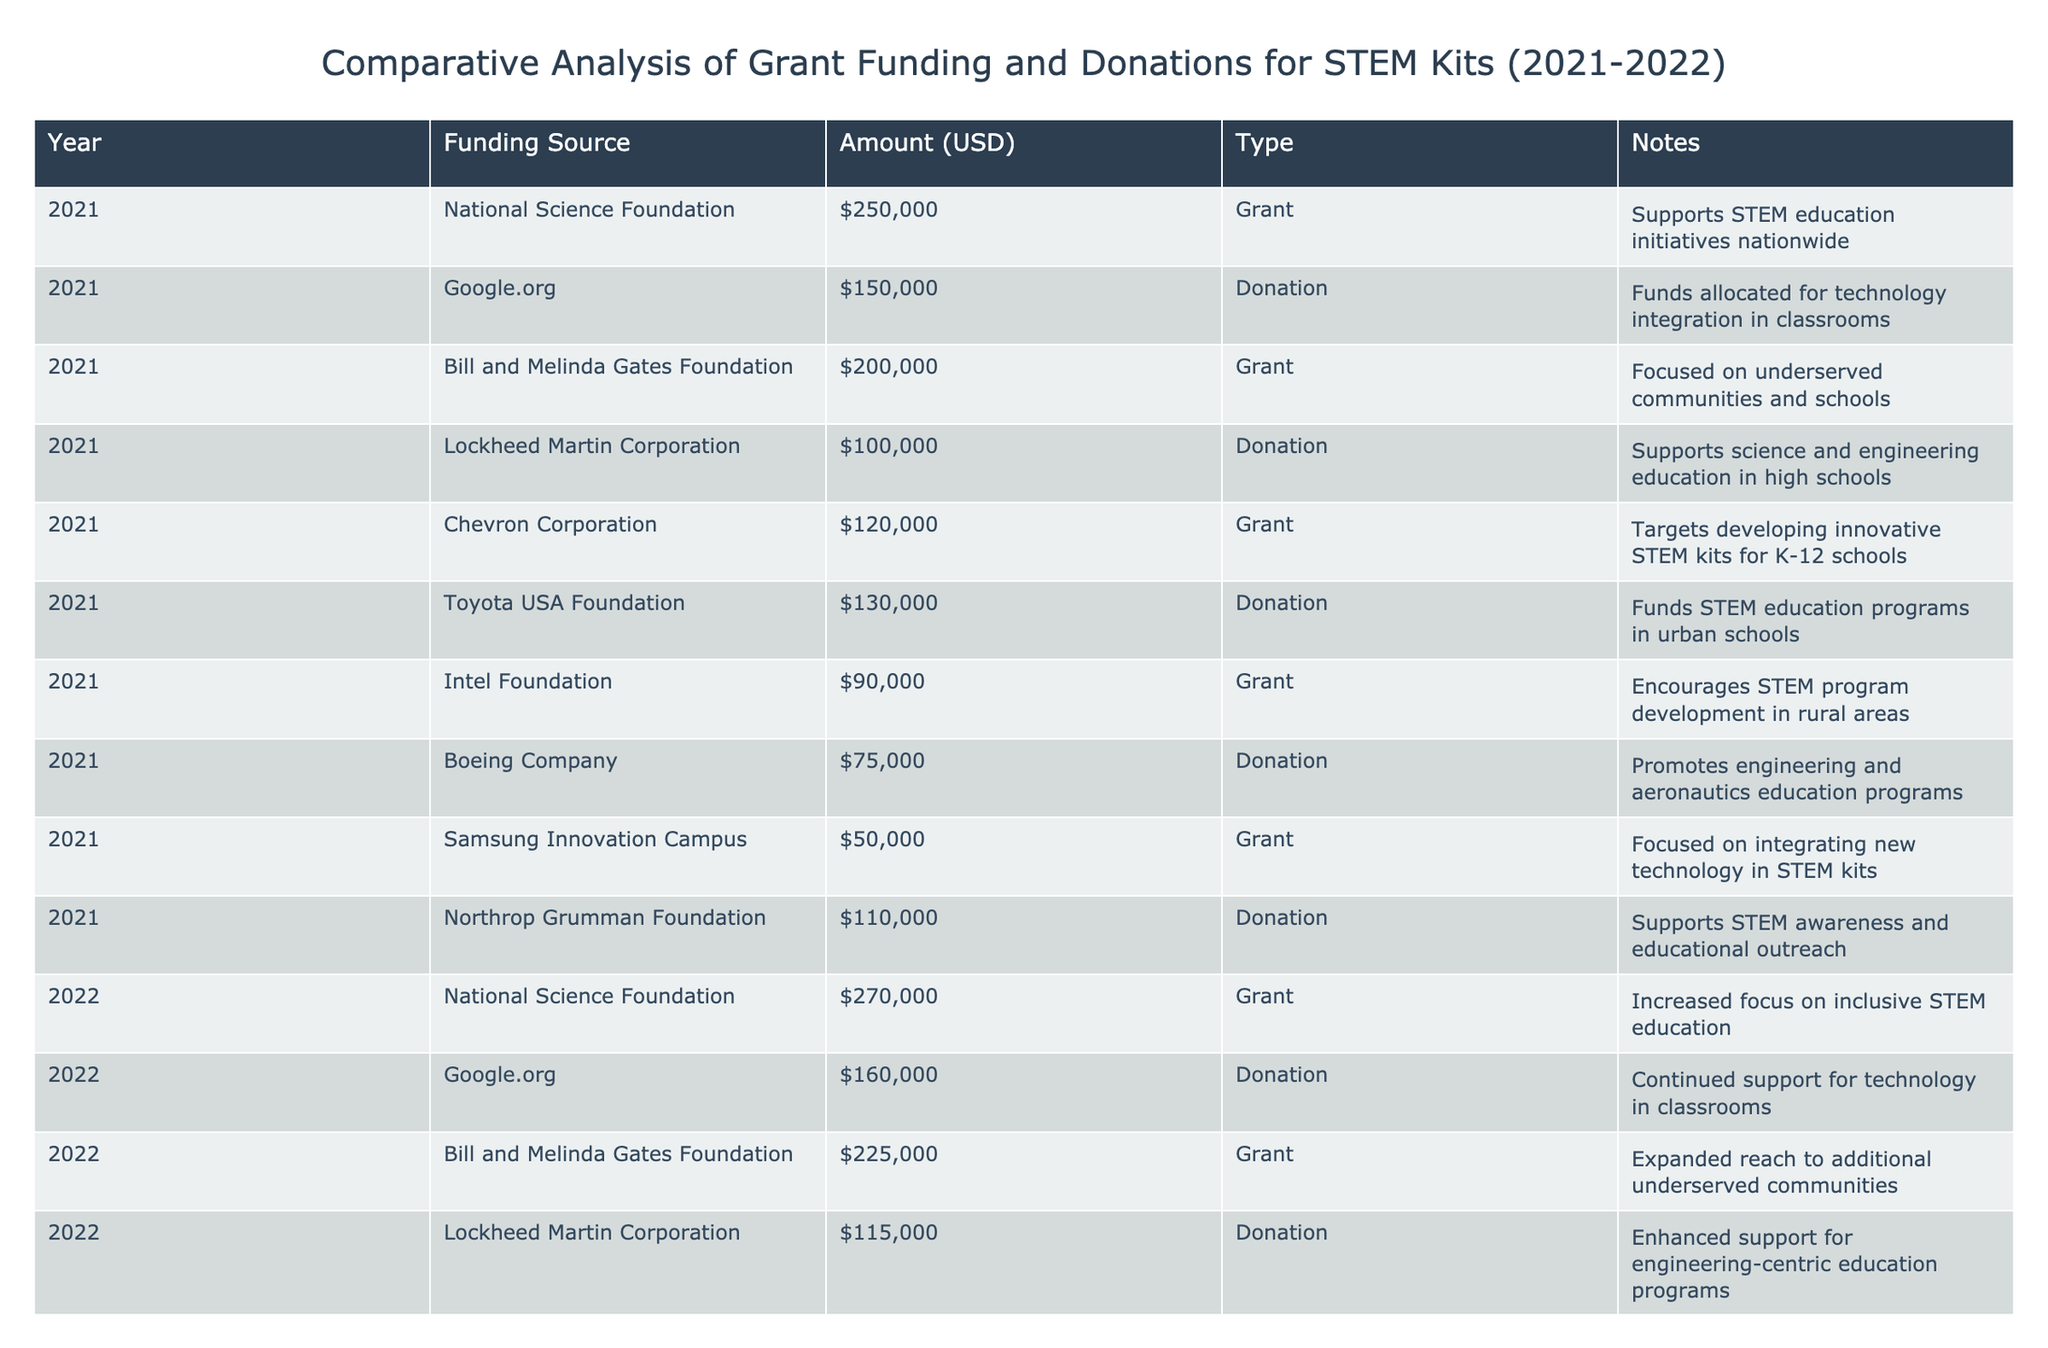What was the total grant funding received in 2021? From the table, the grant funding sources for 2021 are the National Science Foundation ($250,000), Bill and Melinda Gates Foundation ($200,000), Chevron Corporation ($120,000), Intel Foundation ($90,000), Samsung Innovation Campus ($50,000). Adding these amounts together: 250,000 + 200,000 + 120,000 + 90,000 + 50,000 = 710,000.
Answer: 710,000 Which funding source contributed the highest amount in 2022? Looking at the table for 2022, the National Science Foundation provided the highest funding amount of $270,000 compared to other sources listed in that year.
Answer: National Science Foundation Was there an increase in total donations from 2021 to 2022? To determine this, we need to sum the donations for both years. For 2021, the donations total $150,000 (Google.org) + $100,000 (Lockheed Martin) + $130,000 (Toyota USA) + $75,000 (Boeing) + $110,000 (Northrop Grumman) = $565,000. For 2022, the donations total $160,000 (Google.org) + $115,000 (Lockheed Martin) + $140,000 (Toyota USA) + $85,000 (Boeing) + $125,000 (Northrop Grumman) = $625,000. So, $625,000 (2022) - $565,000 (2021) = $60,000 increase, confirming that total donations did indeed increase.
Answer: Yes How much more was received from grants than donations in 2021? In 2021, total grant funding was $710,000 (calculated earlier) and total donations were $565,000 (calculated earlier). The difference is $710,000 - $565,000 = $145,000, meaning grants exceeded donations by this amount.
Answer: 145,000 Did the Bill and Melinda Gates Foundation increase their funding amount from 2021 to 2022? In 2021, the amount from the Bill and Melinda Gates Foundation was $200,000. In 2022, they contributed $225,000. Since $225,000 is greater than $200,000, this indicates an increase in funding.
Answer: Yes What was the average donation received in 2022? The donations for 2022 are: $160,000 (Google.org), $115,000 (Lockheed Martin), $140,000 (Toyota USA), $85,000 (Boeing), and $125,000 (Northrop Grumman). The total donations are $160,000 + $115,000 + $140,000 + $85,000 + $125,000 = $625,000. Since there are 5 donations, the average is $625,000 / 5 = $125,000.
Answer: 125,000 Did Intel Foundation reduce their funding from 2021 to 2022? In 2021, Intel Foundation provided $90,000, and in 2022, they provided $105,000. Since $105,000 is greater than $90,000, this indicates an increase rather than a reduction.
Answer: No What was the percentage increase in total grant funding from 2021 to 2022? Total grant funding for 2021 was $710,000 and for 2022 was calculated to be $1,065,000 (from sources provided). The percentage increase is ((1,065,000 - 710,000) / 710,000) * 100 = 50%.
Answer: 50% 